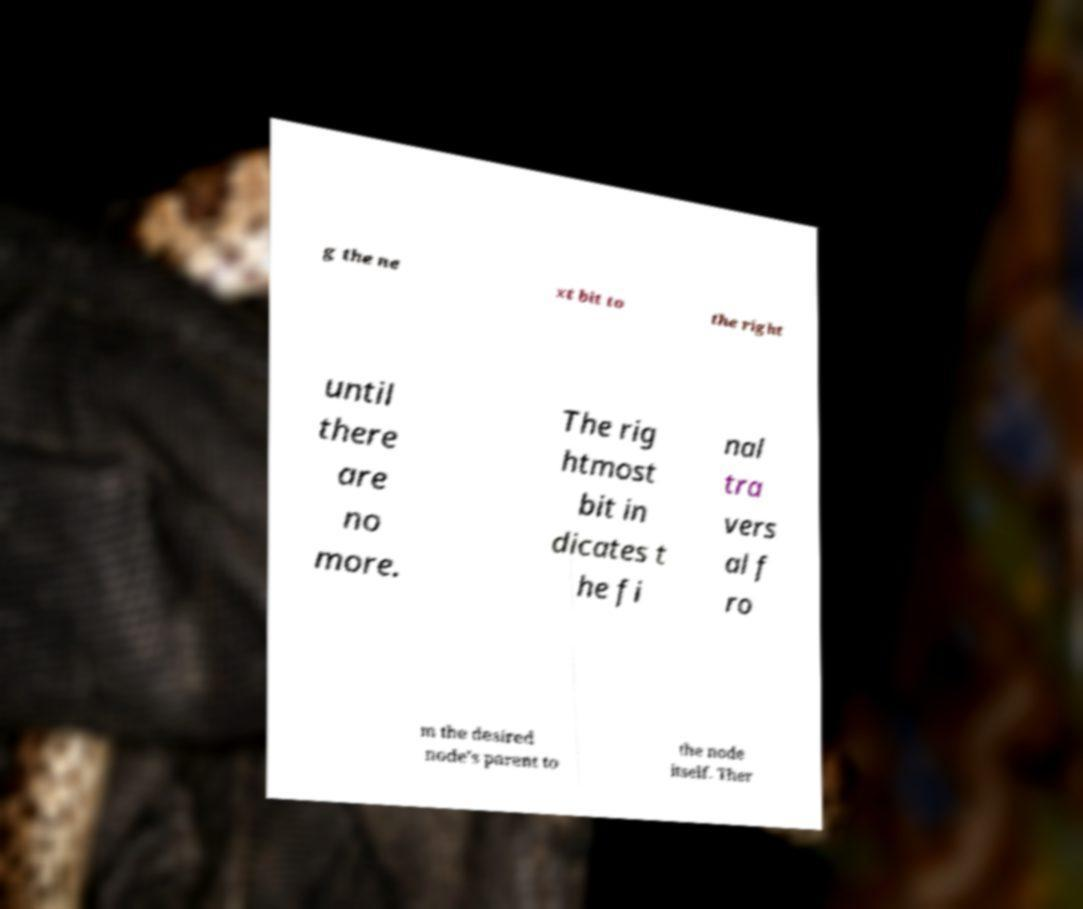Can you read and provide the text displayed in the image?This photo seems to have some interesting text. Can you extract and type it out for me? g the ne xt bit to the right until there are no more. The rig htmost bit in dicates t he fi nal tra vers al f ro m the desired node's parent to the node itself. Ther 